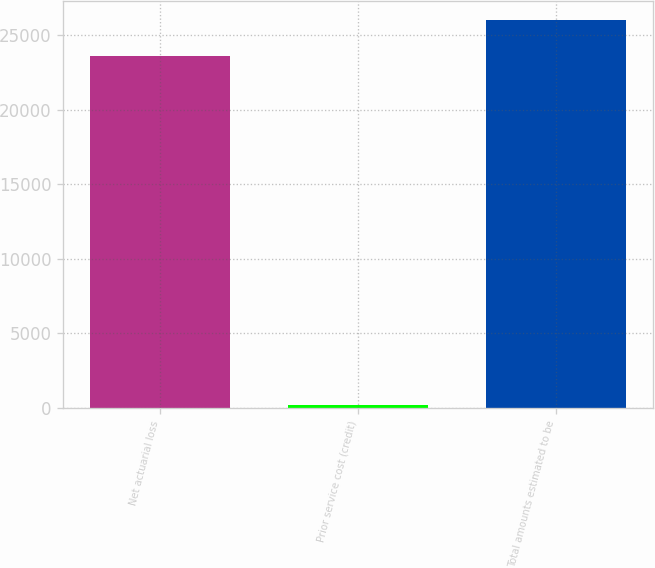Convert chart. <chart><loc_0><loc_0><loc_500><loc_500><bar_chart><fcel>Net actuarial loss<fcel>Prior service cost (credit)<fcel>Total amounts estimated to be<nl><fcel>23638<fcel>179<fcel>26011.2<nl></chart> 